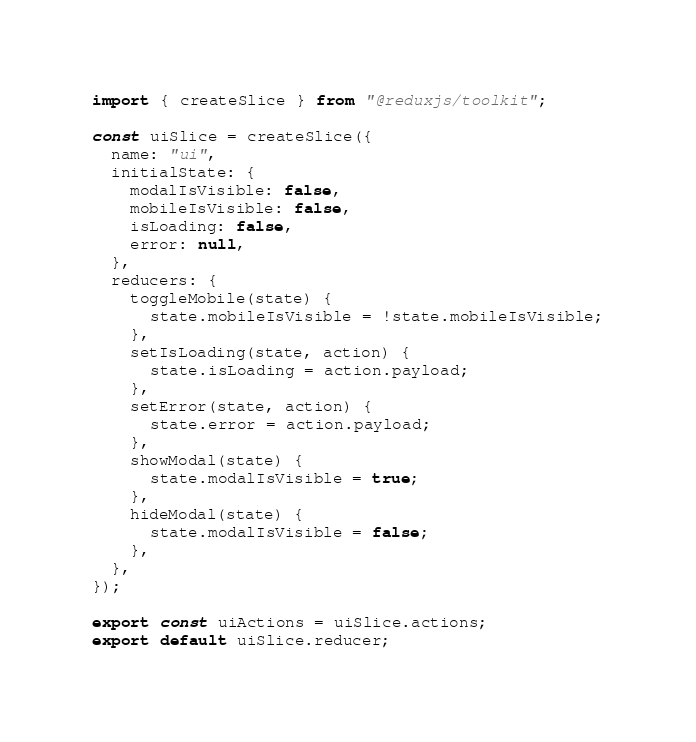Convert code to text. <code><loc_0><loc_0><loc_500><loc_500><_JavaScript_>import { createSlice } from "@reduxjs/toolkit";

const uiSlice = createSlice({
  name: "ui",
  initialState: {
    modalIsVisible: false,
    mobileIsVisible: false,
    isLoading: false,
    error: null,
  },
  reducers: {
    toggleMobile(state) {
      state.mobileIsVisible = !state.mobileIsVisible;
    },
    setIsLoading(state, action) {
      state.isLoading = action.payload;
    },
    setError(state, action) {
      state.error = action.payload;
    },
    showModal(state) {
      state.modalIsVisible = true;
    },
    hideModal(state) {
      state.modalIsVisible = false;
    },
  },
});

export const uiActions = uiSlice.actions;
export default uiSlice.reducer;
</code> 